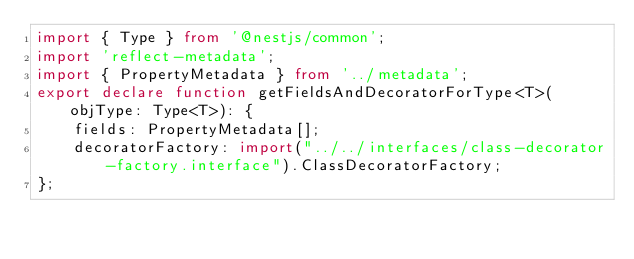<code> <loc_0><loc_0><loc_500><loc_500><_TypeScript_>import { Type } from '@nestjs/common';
import 'reflect-metadata';
import { PropertyMetadata } from '../metadata';
export declare function getFieldsAndDecoratorForType<T>(objType: Type<T>): {
    fields: PropertyMetadata[];
    decoratorFactory: import("../../interfaces/class-decorator-factory.interface").ClassDecoratorFactory;
};
</code> 